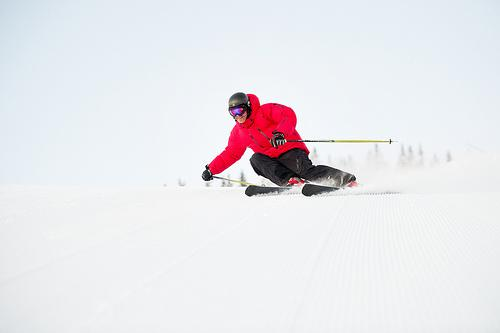Question: why is person leaning?
Choices:
A. He's hurt.
B. Tired.
C. Drunk.
D. Technique.
Answer with the letter. Answer: D Question: what color is skier's jacket?
Choices:
A. Blue.
B. Red.
C. White.
D. Black.
Answer with the letter. Answer: B Question: who is the person?
Choices:
A. Dancer.
B. Skier.
C. Singer.
D. Actor.
Answer with the letter. Answer: B Question: when was picture taken?
Choices:
A. Daytime.
B. Yesterday.
C. Last week.
D. One hour ago.
Answer with the letter. Answer: A Question: what is skier wearing?
Choices:
A. Boots.
B. Suit.
C. Skis.
D. Hat.
Answer with the letter. Answer: C Question: where was picture taken?
Choices:
A. Ski slope.
B. Theme park.
C. Zoo.
D. Carnival.
Answer with the letter. Answer: A 